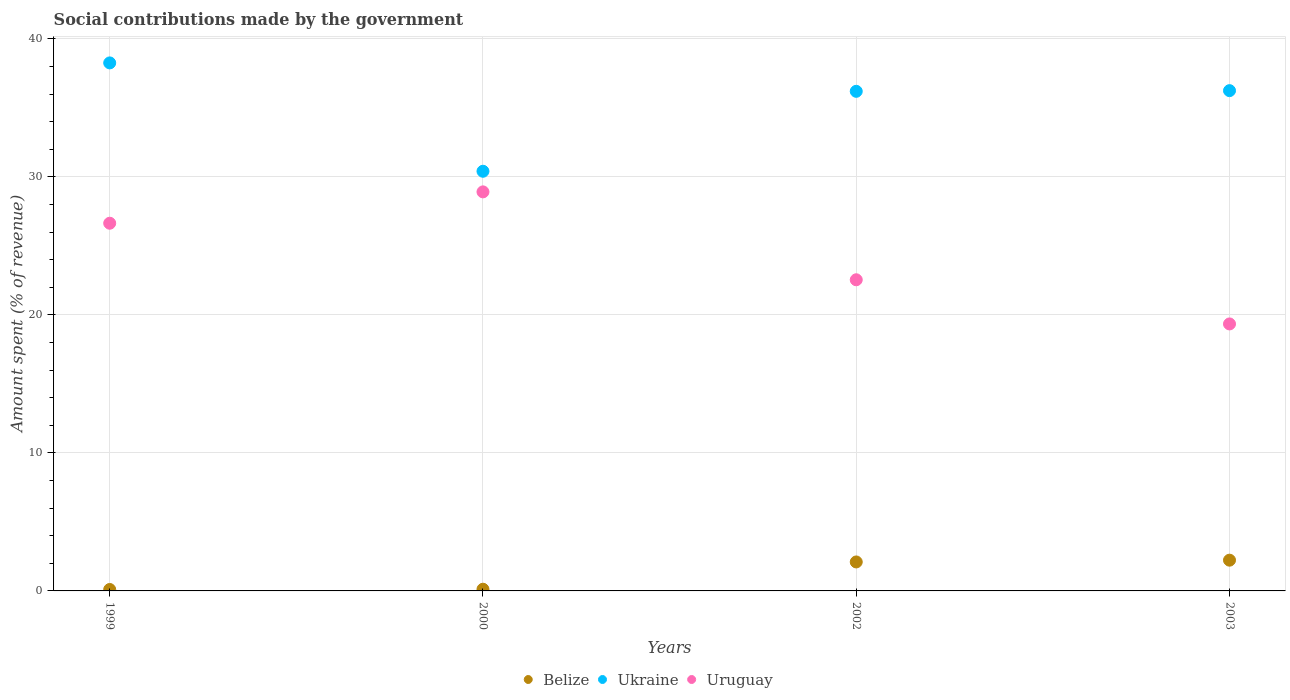How many different coloured dotlines are there?
Provide a short and direct response. 3. What is the amount spent (in %) on social contributions in Ukraine in 1999?
Provide a short and direct response. 38.27. Across all years, what is the maximum amount spent (in %) on social contributions in Uruguay?
Provide a short and direct response. 28.92. Across all years, what is the minimum amount spent (in %) on social contributions in Ukraine?
Offer a very short reply. 30.41. In which year was the amount spent (in %) on social contributions in Belize maximum?
Provide a short and direct response. 2003. What is the total amount spent (in %) on social contributions in Belize in the graph?
Make the answer very short. 4.56. What is the difference between the amount spent (in %) on social contributions in Ukraine in 2000 and that in 2003?
Offer a very short reply. -5.84. What is the difference between the amount spent (in %) on social contributions in Belize in 2003 and the amount spent (in %) on social contributions in Uruguay in 1999?
Your answer should be compact. -24.42. What is the average amount spent (in %) on social contributions in Belize per year?
Your answer should be very brief. 1.14. In the year 1999, what is the difference between the amount spent (in %) on social contributions in Ukraine and amount spent (in %) on social contributions in Belize?
Keep it short and to the point. 38.16. What is the ratio of the amount spent (in %) on social contributions in Ukraine in 2000 to that in 2003?
Provide a short and direct response. 0.84. What is the difference between the highest and the second highest amount spent (in %) on social contributions in Belize?
Provide a succinct answer. 0.13. What is the difference between the highest and the lowest amount spent (in %) on social contributions in Uruguay?
Your response must be concise. 9.57. Is the sum of the amount spent (in %) on social contributions in Ukraine in 1999 and 2002 greater than the maximum amount spent (in %) on social contributions in Belize across all years?
Keep it short and to the point. Yes. Is the amount spent (in %) on social contributions in Ukraine strictly greater than the amount spent (in %) on social contributions in Belize over the years?
Your answer should be compact. Yes. How many dotlines are there?
Your answer should be compact. 3. What is the difference between two consecutive major ticks on the Y-axis?
Make the answer very short. 10. Does the graph contain grids?
Your answer should be compact. Yes. Where does the legend appear in the graph?
Keep it short and to the point. Bottom center. How are the legend labels stacked?
Your answer should be very brief. Horizontal. What is the title of the graph?
Your response must be concise. Social contributions made by the government. What is the label or title of the Y-axis?
Your response must be concise. Amount spent (% of revenue). What is the Amount spent (% of revenue) of Belize in 1999?
Your answer should be compact. 0.1. What is the Amount spent (% of revenue) of Ukraine in 1999?
Make the answer very short. 38.27. What is the Amount spent (% of revenue) of Uruguay in 1999?
Ensure brevity in your answer.  26.65. What is the Amount spent (% of revenue) in Belize in 2000?
Your answer should be very brief. 0.12. What is the Amount spent (% of revenue) of Ukraine in 2000?
Make the answer very short. 30.41. What is the Amount spent (% of revenue) of Uruguay in 2000?
Offer a terse response. 28.92. What is the Amount spent (% of revenue) of Belize in 2002?
Provide a short and direct response. 2.1. What is the Amount spent (% of revenue) of Ukraine in 2002?
Offer a terse response. 36.21. What is the Amount spent (% of revenue) in Uruguay in 2002?
Give a very brief answer. 22.55. What is the Amount spent (% of revenue) in Belize in 2003?
Your answer should be compact. 2.23. What is the Amount spent (% of revenue) of Ukraine in 2003?
Your answer should be compact. 36.26. What is the Amount spent (% of revenue) in Uruguay in 2003?
Your answer should be very brief. 19.35. Across all years, what is the maximum Amount spent (% of revenue) of Belize?
Your answer should be compact. 2.23. Across all years, what is the maximum Amount spent (% of revenue) of Ukraine?
Offer a very short reply. 38.27. Across all years, what is the maximum Amount spent (% of revenue) of Uruguay?
Offer a very short reply. 28.92. Across all years, what is the minimum Amount spent (% of revenue) of Belize?
Keep it short and to the point. 0.1. Across all years, what is the minimum Amount spent (% of revenue) of Ukraine?
Keep it short and to the point. 30.41. Across all years, what is the minimum Amount spent (% of revenue) in Uruguay?
Make the answer very short. 19.35. What is the total Amount spent (% of revenue) in Belize in the graph?
Your answer should be compact. 4.56. What is the total Amount spent (% of revenue) of Ukraine in the graph?
Provide a succinct answer. 141.15. What is the total Amount spent (% of revenue) of Uruguay in the graph?
Make the answer very short. 97.47. What is the difference between the Amount spent (% of revenue) of Belize in 1999 and that in 2000?
Offer a terse response. -0.02. What is the difference between the Amount spent (% of revenue) in Ukraine in 1999 and that in 2000?
Your response must be concise. 7.85. What is the difference between the Amount spent (% of revenue) of Uruguay in 1999 and that in 2000?
Your response must be concise. -2.27. What is the difference between the Amount spent (% of revenue) in Belize in 1999 and that in 2002?
Your answer should be compact. -2. What is the difference between the Amount spent (% of revenue) of Ukraine in 1999 and that in 2002?
Make the answer very short. 2.06. What is the difference between the Amount spent (% of revenue) in Uruguay in 1999 and that in 2002?
Make the answer very short. 4.1. What is the difference between the Amount spent (% of revenue) in Belize in 1999 and that in 2003?
Give a very brief answer. -2.12. What is the difference between the Amount spent (% of revenue) in Ukraine in 1999 and that in 2003?
Your answer should be compact. 2.01. What is the difference between the Amount spent (% of revenue) in Uruguay in 1999 and that in 2003?
Your answer should be very brief. 7.3. What is the difference between the Amount spent (% of revenue) of Belize in 2000 and that in 2002?
Your answer should be very brief. -1.98. What is the difference between the Amount spent (% of revenue) of Ukraine in 2000 and that in 2002?
Your answer should be compact. -5.79. What is the difference between the Amount spent (% of revenue) in Uruguay in 2000 and that in 2002?
Offer a very short reply. 6.37. What is the difference between the Amount spent (% of revenue) of Belize in 2000 and that in 2003?
Provide a succinct answer. -2.11. What is the difference between the Amount spent (% of revenue) of Ukraine in 2000 and that in 2003?
Give a very brief answer. -5.84. What is the difference between the Amount spent (% of revenue) of Uruguay in 2000 and that in 2003?
Give a very brief answer. 9.57. What is the difference between the Amount spent (% of revenue) in Belize in 2002 and that in 2003?
Provide a short and direct response. -0.13. What is the difference between the Amount spent (% of revenue) in Ukraine in 2002 and that in 2003?
Your answer should be very brief. -0.05. What is the difference between the Amount spent (% of revenue) in Uruguay in 2002 and that in 2003?
Offer a terse response. 3.2. What is the difference between the Amount spent (% of revenue) in Belize in 1999 and the Amount spent (% of revenue) in Ukraine in 2000?
Your answer should be compact. -30.31. What is the difference between the Amount spent (% of revenue) of Belize in 1999 and the Amount spent (% of revenue) of Uruguay in 2000?
Ensure brevity in your answer.  -28.82. What is the difference between the Amount spent (% of revenue) in Ukraine in 1999 and the Amount spent (% of revenue) in Uruguay in 2000?
Keep it short and to the point. 9.35. What is the difference between the Amount spent (% of revenue) of Belize in 1999 and the Amount spent (% of revenue) of Ukraine in 2002?
Keep it short and to the point. -36.1. What is the difference between the Amount spent (% of revenue) of Belize in 1999 and the Amount spent (% of revenue) of Uruguay in 2002?
Offer a very short reply. -22.45. What is the difference between the Amount spent (% of revenue) in Ukraine in 1999 and the Amount spent (% of revenue) in Uruguay in 2002?
Make the answer very short. 15.72. What is the difference between the Amount spent (% of revenue) in Belize in 1999 and the Amount spent (% of revenue) in Ukraine in 2003?
Provide a short and direct response. -36.15. What is the difference between the Amount spent (% of revenue) in Belize in 1999 and the Amount spent (% of revenue) in Uruguay in 2003?
Your answer should be compact. -19.25. What is the difference between the Amount spent (% of revenue) in Ukraine in 1999 and the Amount spent (% of revenue) in Uruguay in 2003?
Your answer should be compact. 18.92. What is the difference between the Amount spent (% of revenue) in Belize in 2000 and the Amount spent (% of revenue) in Ukraine in 2002?
Provide a short and direct response. -36.09. What is the difference between the Amount spent (% of revenue) in Belize in 2000 and the Amount spent (% of revenue) in Uruguay in 2002?
Your answer should be compact. -22.43. What is the difference between the Amount spent (% of revenue) of Ukraine in 2000 and the Amount spent (% of revenue) of Uruguay in 2002?
Provide a short and direct response. 7.86. What is the difference between the Amount spent (% of revenue) in Belize in 2000 and the Amount spent (% of revenue) in Ukraine in 2003?
Your response must be concise. -36.13. What is the difference between the Amount spent (% of revenue) of Belize in 2000 and the Amount spent (% of revenue) of Uruguay in 2003?
Give a very brief answer. -19.23. What is the difference between the Amount spent (% of revenue) of Ukraine in 2000 and the Amount spent (% of revenue) of Uruguay in 2003?
Your answer should be very brief. 11.06. What is the difference between the Amount spent (% of revenue) in Belize in 2002 and the Amount spent (% of revenue) in Ukraine in 2003?
Offer a very short reply. -34.16. What is the difference between the Amount spent (% of revenue) of Belize in 2002 and the Amount spent (% of revenue) of Uruguay in 2003?
Ensure brevity in your answer.  -17.25. What is the difference between the Amount spent (% of revenue) in Ukraine in 2002 and the Amount spent (% of revenue) in Uruguay in 2003?
Make the answer very short. 16.86. What is the average Amount spent (% of revenue) of Belize per year?
Provide a short and direct response. 1.14. What is the average Amount spent (% of revenue) of Ukraine per year?
Give a very brief answer. 35.29. What is the average Amount spent (% of revenue) of Uruguay per year?
Provide a short and direct response. 24.37. In the year 1999, what is the difference between the Amount spent (% of revenue) in Belize and Amount spent (% of revenue) in Ukraine?
Provide a short and direct response. -38.16. In the year 1999, what is the difference between the Amount spent (% of revenue) in Belize and Amount spent (% of revenue) in Uruguay?
Give a very brief answer. -26.54. In the year 1999, what is the difference between the Amount spent (% of revenue) of Ukraine and Amount spent (% of revenue) of Uruguay?
Your response must be concise. 11.62. In the year 2000, what is the difference between the Amount spent (% of revenue) in Belize and Amount spent (% of revenue) in Ukraine?
Your response must be concise. -30.29. In the year 2000, what is the difference between the Amount spent (% of revenue) in Belize and Amount spent (% of revenue) in Uruguay?
Ensure brevity in your answer.  -28.8. In the year 2000, what is the difference between the Amount spent (% of revenue) of Ukraine and Amount spent (% of revenue) of Uruguay?
Offer a very short reply. 1.49. In the year 2002, what is the difference between the Amount spent (% of revenue) of Belize and Amount spent (% of revenue) of Ukraine?
Offer a terse response. -34.11. In the year 2002, what is the difference between the Amount spent (% of revenue) in Belize and Amount spent (% of revenue) in Uruguay?
Provide a succinct answer. -20.45. In the year 2002, what is the difference between the Amount spent (% of revenue) of Ukraine and Amount spent (% of revenue) of Uruguay?
Your answer should be very brief. 13.66. In the year 2003, what is the difference between the Amount spent (% of revenue) in Belize and Amount spent (% of revenue) in Ukraine?
Offer a terse response. -34.03. In the year 2003, what is the difference between the Amount spent (% of revenue) of Belize and Amount spent (% of revenue) of Uruguay?
Keep it short and to the point. -17.12. In the year 2003, what is the difference between the Amount spent (% of revenue) of Ukraine and Amount spent (% of revenue) of Uruguay?
Give a very brief answer. 16.91. What is the ratio of the Amount spent (% of revenue) in Belize in 1999 to that in 2000?
Provide a succinct answer. 0.85. What is the ratio of the Amount spent (% of revenue) in Ukraine in 1999 to that in 2000?
Provide a short and direct response. 1.26. What is the ratio of the Amount spent (% of revenue) of Uruguay in 1999 to that in 2000?
Give a very brief answer. 0.92. What is the ratio of the Amount spent (% of revenue) in Belize in 1999 to that in 2002?
Provide a short and direct response. 0.05. What is the ratio of the Amount spent (% of revenue) of Ukraine in 1999 to that in 2002?
Offer a very short reply. 1.06. What is the ratio of the Amount spent (% of revenue) of Uruguay in 1999 to that in 2002?
Your answer should be very brief. 1.18. What is the ratio of the Amount spent (% of revenue) of Belize in 1999 to that in 2003?
Keep it short and to the point. 0.05. What is the ratio of the Amount spent (% of revenue) of Ukraine in 1999 to that in 2003?
Your answer should be compact. 1.06. What is the ratio of the Amount spent (% of revenue) of Uruguay in 1999 to that in 2003?
Your answer should be very brief. 1.38. What is the ratio of the Amount spent (% of revenue) of Belize in 2000 to that in 2002?
Provide a succinct answer. 0.06. What is the ratio of the Amount spent (% of revenue) of Ukraine in 2000 to that in 2002?
Your answer should be very brief. 0.84. What is the ratio of the Amount spent (% of revenue) of Uruguay in 2000 to that in 2002?
Your response must be concise. 1.28. What is the ratio of the Amount spent (% of revenue) of Belize in 2000 to that in 2003?
Provide a succinct answer. 0.06. What is the ratio of the Amount spent (% of revenue) in Ukraine in 2000 to that in 2003?
Give a very brief answer. 0.84. What is the ratio of the Amount spent (% of revenue) in Uruguay in 2000 to that in 2003?
Your answer should be very brief. 1.49. What is the ratio of the Amount spent (% of revenue) of Belize in 2002 to that in 2003?
Offer a very short reply. 0.94. What is the ratio of the Amount spent (% of revenue) in Ukraine in 2002 to that in 2003?
Provide a short and direct response. 1. What is the ratio of the Amount spent (% of revenue) in Uruguay in 2002 to that in 2003?
Offer a terse response. 1.17. What is the difference between the highest and the second highest Amount spent (% of revenue) of Belize?
Offer a very short reply. 0.13. What is the difference between the highest and the second highest Amount spent (% of revenue) of Ukraine?
Your response must be concise. 2.01. What is the difference between the highest and the second highest Amount spent (% of revenue) in Uruguay?
Your answer should be very brief. 2.27. What is the difference between the highest and the lowest Amount spent (% of revenue) of Belize?
Offer a very short reply. 2.12. What is the difference between the highest and the lowest Amount spent (% of revenue) of Ukraine?
Provide a short and direct response. 7.85. What is the difference between the highest and the lowest Amount spent (% of revenue) in Uruguay?
Ensure brevity in your answer.  9.57. 